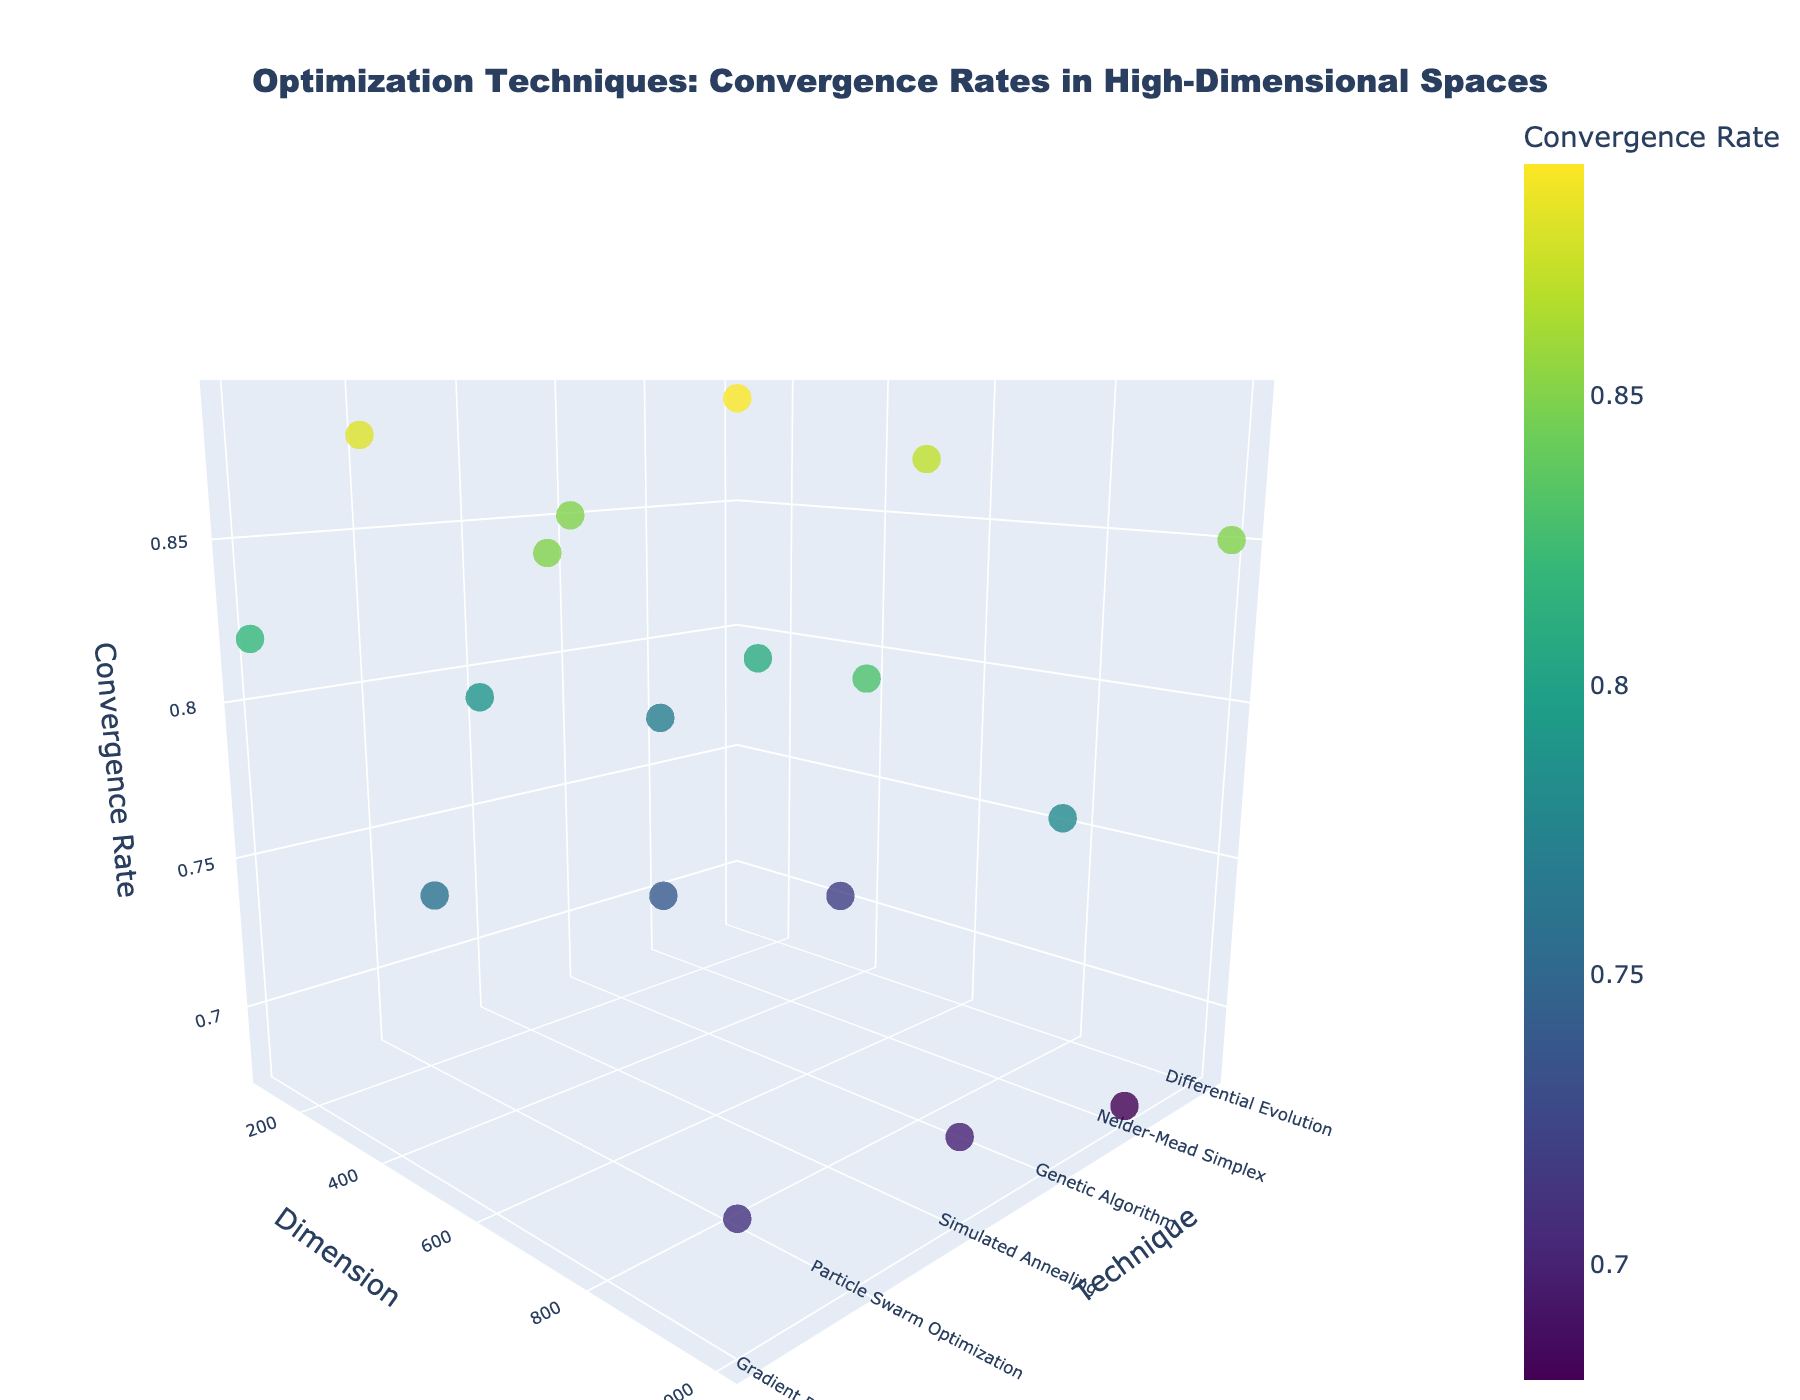What's the title of the plot? The title is usually found at the top center of the plot. In this case, it indicates the subject of the analysis by highlighting the convergence rates of different optimization techniques in high-dimensional spaces.
Answer: Optimization Techniques: Convergence Rates in High-Dimensional Spaces Which axis represents the dimension? The x-axis represents the dimension, as labeled. It shows different high-dimensional spaces where the optimization techniques are applied, indicated by numbers (100, 500, 1000).
Answer: x-axis Which optimization technique has the highest convergence rate in a 1000-dimensional space? Locate the points where the dimension is 1000 on the x-axis and identify the technique with the highest value on the z-axis, which represents the convergence rate. Differential Evolution has the highest convergence rate of 0.85 at this dimension.
Answer: Differential Evolution What color scale is used for the convergence rate markers? The color of each marker varies according to the convergence rate and is based on the 'Viridis' color scale, as indicated by the code and verified visually on the plot’s color bar.
Answer: Viridis How does the convergence rate for Gradient Descent change as the dimension increases from 100 to 1000? Locate the data points for Gradient Descent on the y-axis at dimensions 100, 500, and 1000. Observe their corresponding z-values (convergence rates). The convergence rate decreases from 0.82 at dimension 100 to 0.71 at dimension 1000.
Answer: It decreases Compare the convergence rates between Particle Swarm Optimization and Genetic Algorithm in a 500-dimensional space. Locate the convergence rates for Particle Swarm Optimization and Genetic Algorithm at dimension 500 on the x-axis. For Particle Swarm Optimization, the convergence rate is 0.85, and for Genetic Algorithm, it is 0.81.
Answer: Particle Swarm Optimization is higher What is the difference in convergence rates between Simulated Annealing and Nelder-Mead Simplex for a 100-dimensional space? Locate and compare the convergence rates for Simulated Annealing and Nelder-Mead Simplex at dimension 100. Simulated Annealing has a rate of 0.79 and Nelder-Mead Simplex has 0.77. Calculate the difference, which is 0.79 - 0.77 = 0.02.
Answer: 0.02 Which technique shows the least change in convergence rate from 100 to 1000 dimensions? For each technique, calculate the difference in convergence rates between dimension 100 and 1000. Compare the results to determine the technique with the smallest change. Differential Evolution changes from 0.89 to 0.85, showing the least change of 0.04.
Answer: Differential Evolution What patterns can you observe in the convergence rates as the dimensionality increases? Examine the plot and observe the trend lines for each technique. Most techniques show a general decrease in convergence rate as the dimensionality increases from 100 to 1000.
Answer: General decrease How do the convergence rates of Differential Evolution and Particle Swarm Optimization compare across all dimensions? Visualize the data points for Differential Evolution and Particle Swarm Optimization across all dimensions. Both techniques have high convergence rates, but Differential Evolution is consistently higher.
Answer: Differential Evolution is higher 